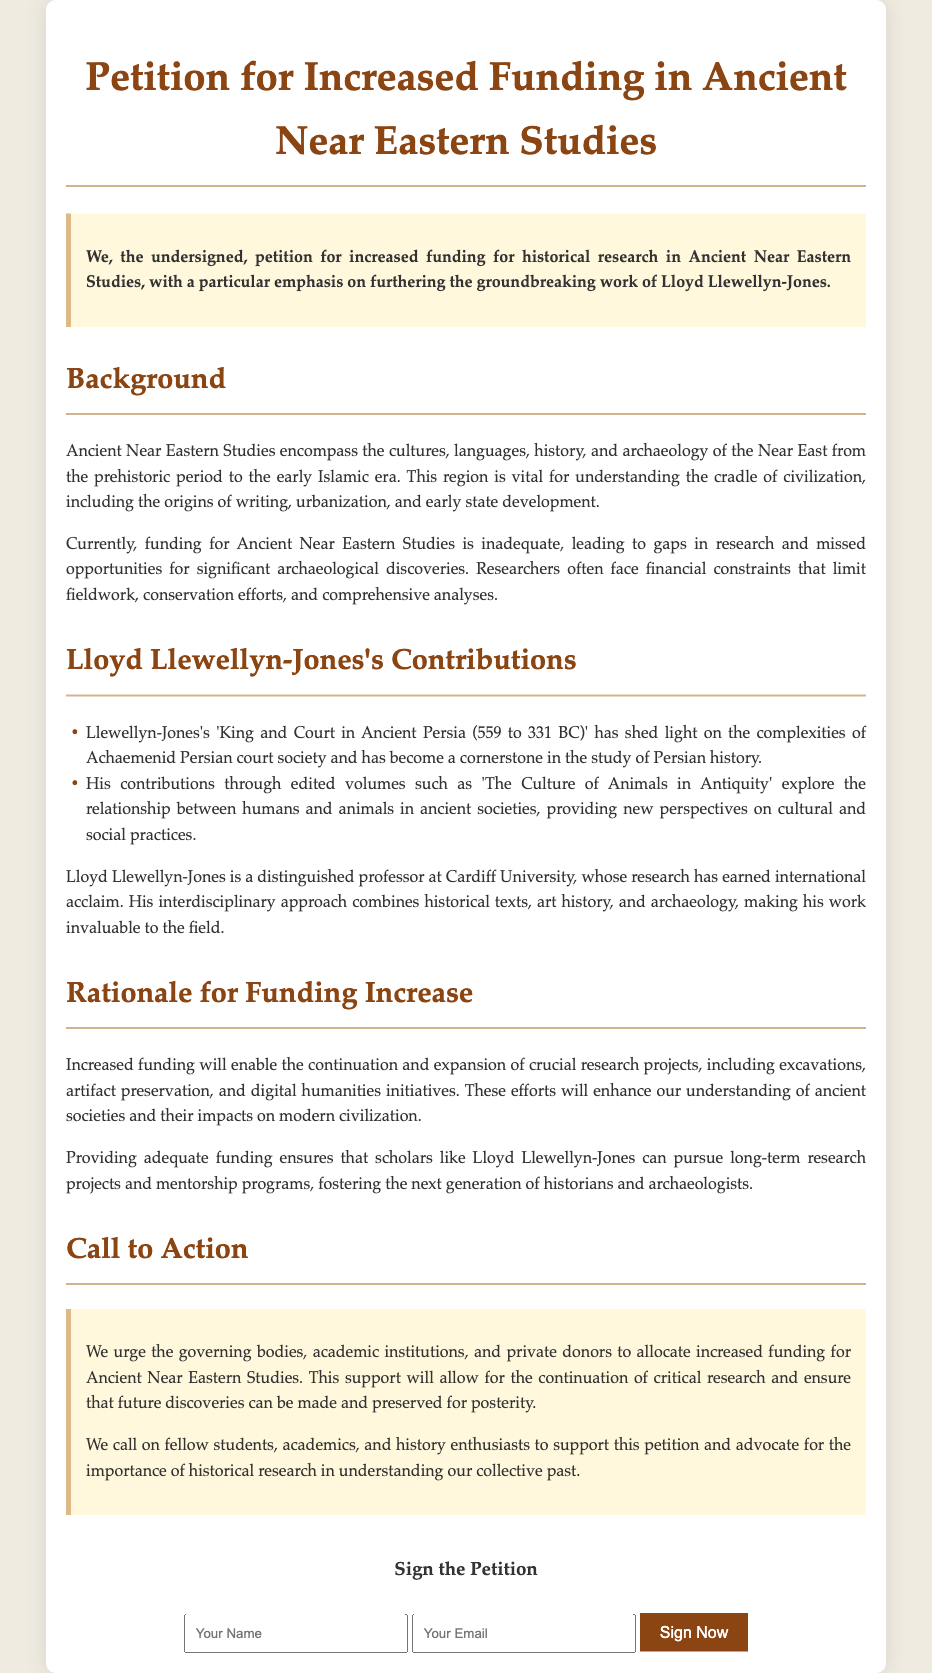What is the title of the petition? The title of the petition is explicitly stated at the beginning of the document.
Answer: Petition for Increased Funding in Ancient Near Eastern Studies Who is the distinguished professor mentioned in the petition? The document specifically identifies the academic figure whose contributions are highlighted.
Answer: Lloyd Llewellyn-Jones What is one of the works authored by Lloyd Llewellyn-Jones? The petition lists notable works by the professor as part of his contributions to the field.
Answer: King and Court in Ancient Persia (559 to 331 BC) What type of studies does the petition focus on? The document clearly defines the area of focus for the funding request.
Answer: Ancient Near Eastern Studies What is a proposed benefit of increased funding mentioned in the petition? The rationale for increased funding includes various benefits that support research projects.
Answer: Continuation and expansion of crucial research projects What are we urging governing bodies to do? The petition includes a specific call to action directed towards entities responsible for funding.
Answer: Allocate increased funding How many contributions of Lloyd Llewellyn-Jones are listed in the document? The enumerated list within the document indicates how many of his contributions are highlighted.
Answer: Two 